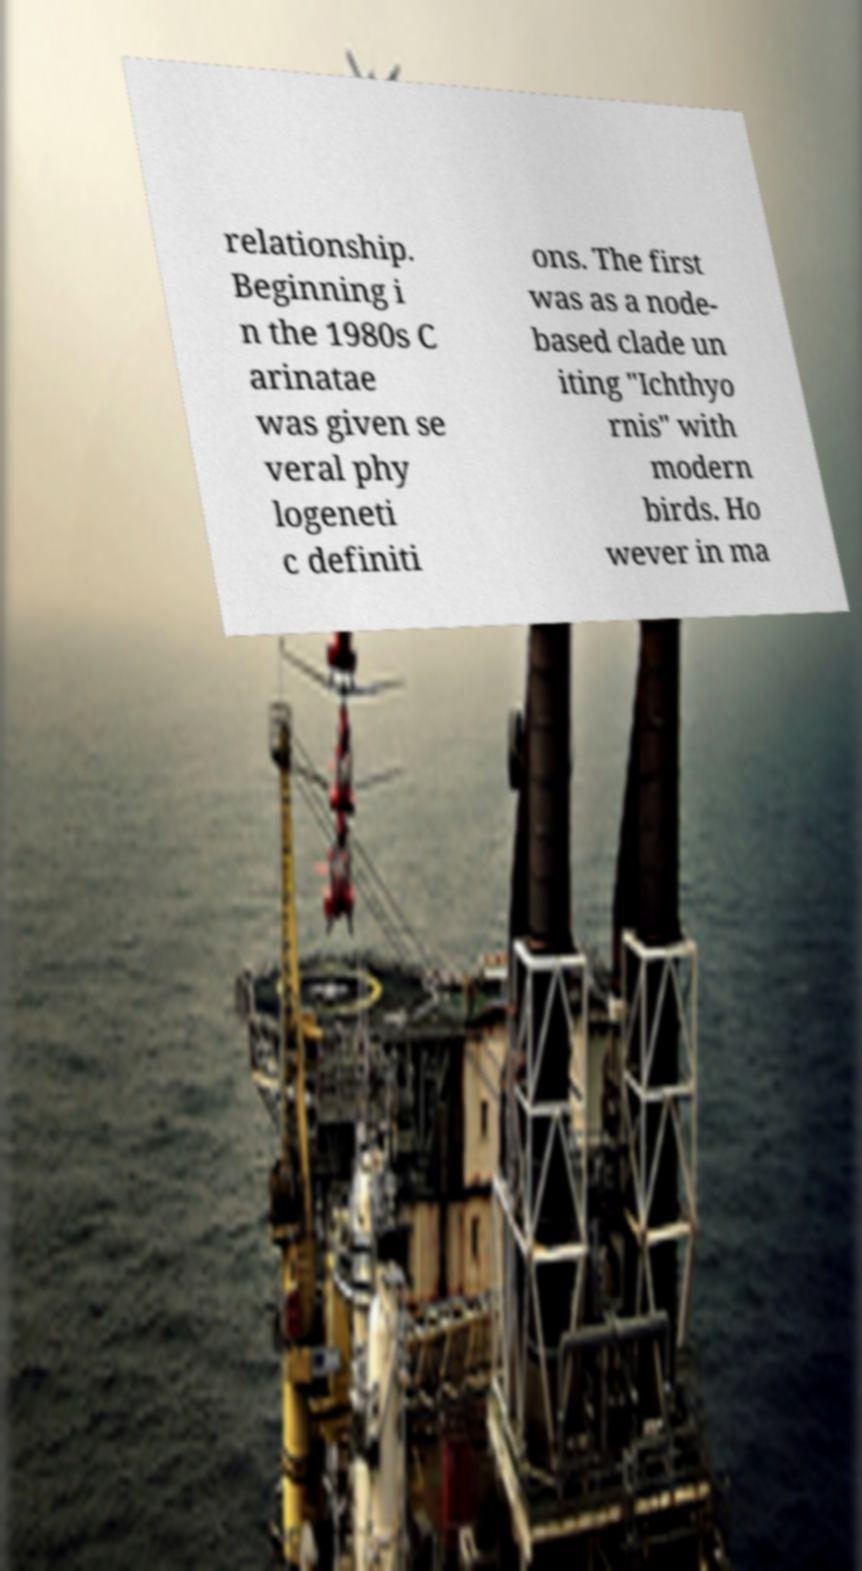I need the written content from this picture converted into text. Can you do that? relationship. Beginning i n the 1980s C arinatae was given se veral phy logeneti c definiti ons. The first was as a node- based clade un iting "Ichthyo rnis" with modern birds. Ho wever in ma 